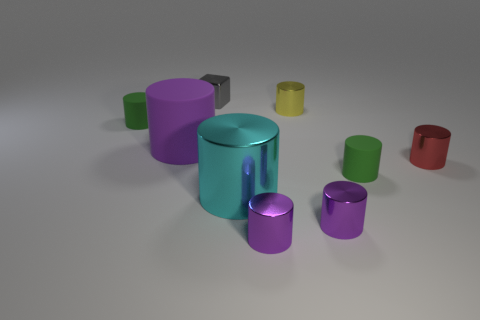Subtract all purple spheres. How many purple cylinders are left? 3 Subtract all yellow cylinders. How many cylinders are left? 7 Subtract all small green matte cylinders. How many cylinders are left? 6 Subtract all cyan cylinders. Subtract all yellow blocks. How many cylinders are left? 7 Add 1 tiny brown metallic cubes. How many objects exist? 10 Subtract all cylinders. How many objects are left? 1 Subtract 0 purple blocks. How many objects are left? 9 Subtract all red metal objects. Subtract all tiny green matte cylinders. How many objects are left? 6 Add 5 gray cubes. How many gray cubes are left? 6 Add 5 big green things. How many big green things exist? 5 